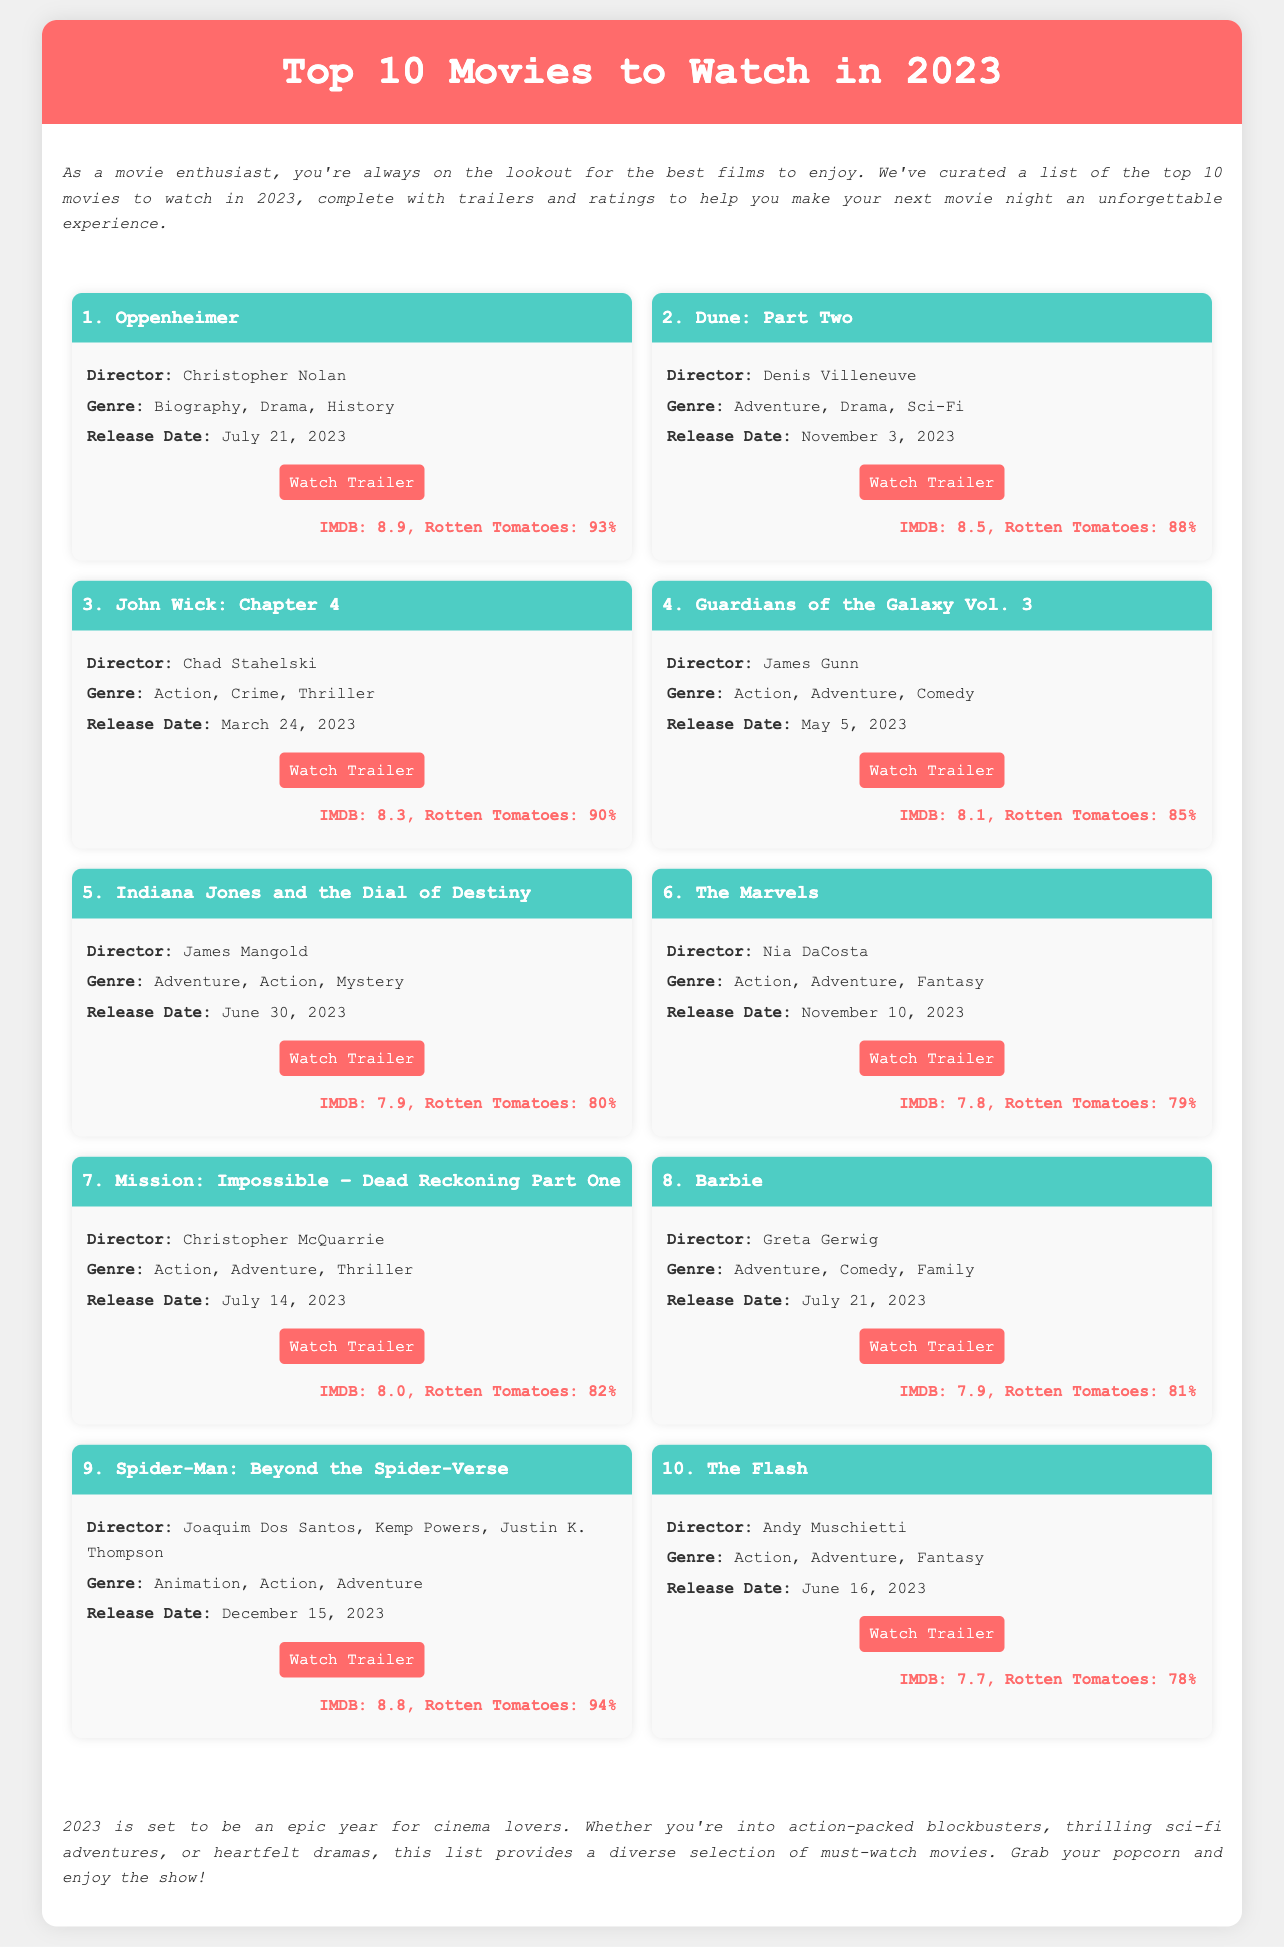What is the title of the first movie? The first movie listed in the document is "Oppenheimer."
Answer: Oppenheimer Who directed "Dune: Part Two"? The director of "Dune: Part Two" is Denis Villeneuve.
Answer: Denis Villeneuve What is the release date of "Mission: Impossible – Dead Reckoning Part One"? The document states that "Mission: Impossible – Dead Reckoning Part One" was released on July 14, 2023.
Answer: July 14, 2023 Which movie has an IMDB rating of 8.8? The movie "Spider-Man: Beyond the Spider-Verse" has an IMDB rating of 8.8.
Answer: Spider-Man: Beyond the Spider-Verse Which genre is associated with "Barbie"? The document describes "Barbie" as an Adventure, Comedy, Family movie.
Answer: Adventure, Comedy, Family How many movies are released in June 2023 according to the document? The document lists two movies released in June 2023: "Indiana Jones and the Dial of Destiny" and "The Flash."
Answer: 2 What is the Rotten Tomatoes score for "Guardians of the Galaxy Vol. 3"? "Guardians of the Galaxy Vol. 3" has a Rotten Tomatoes score of 85%.
Answer: 85% Which movie is expected to be released on December 15, 2023? The movie "Spider-Man: Beyond the Spider-Verse" is expected to be released on that date.
Answer: Spider-Man: Beyond the Spider-Verse What type of document is this? This document is a datasheet listing movies with details such as trailers and ratings.
Answer: Datasheet 